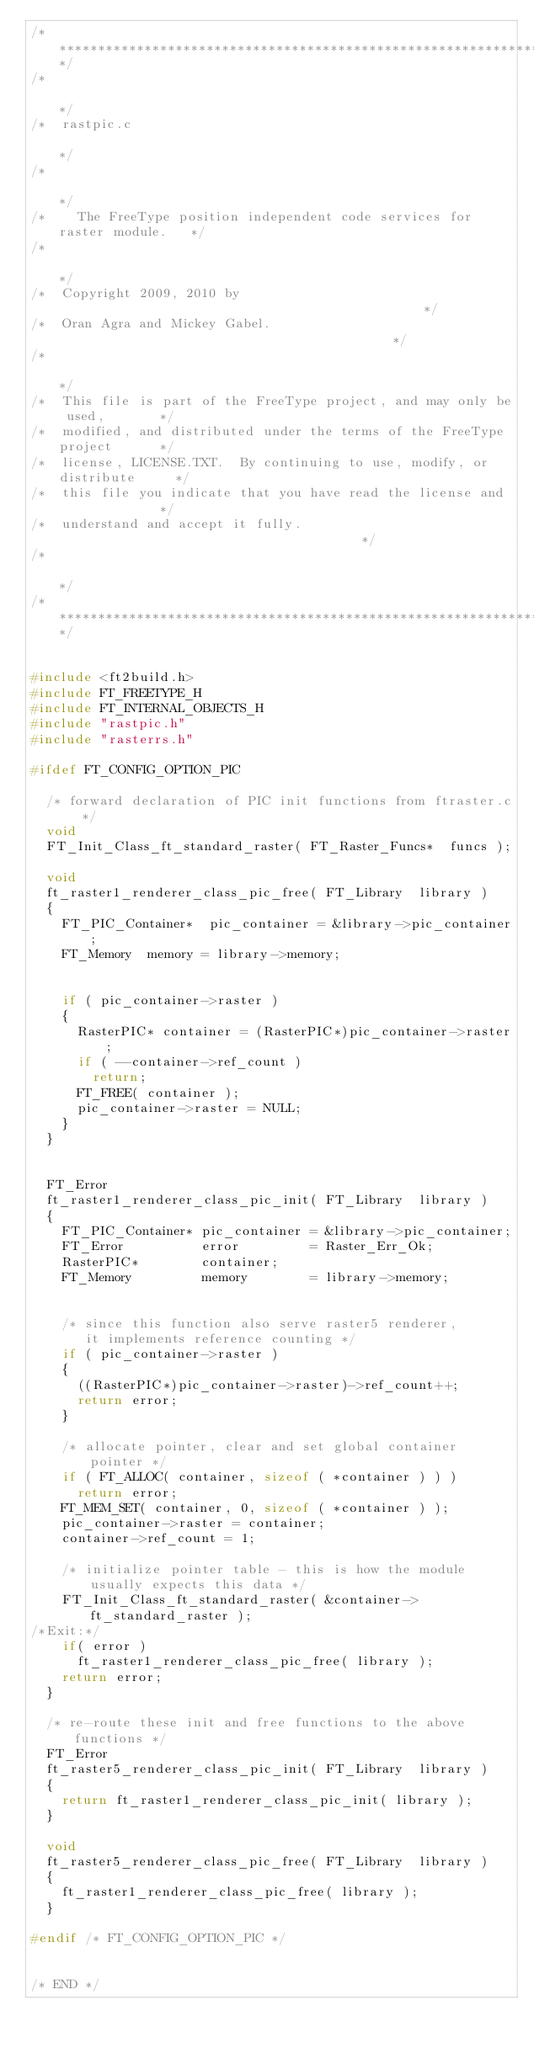Convert code to text. <code><loc_0><loc_0><loc_500><loc_500><_C_>/***************************************************************************/
/*                                                                         */
/*  rastpic.c                                                              */
/*                                                                         */
/*    The FreeType position independent code services for raster module.   */
/*                                                                         */
/*  Copyright 2009, 2010 by                                                */
/*  Oran Agra and Mickey Gabel.                                            */
/*                                                                         */
/*  This file is part of the FreeType project, and may only be used,       */
/*  modified, and distributed under the terms of the FreeType project      */
/*  license, LICENSE.TXT.  By continuing to use, modify, or distribute     */
/*  this file you indicate that you have read the license and              */
/*  understand and accept it fully.                                        */
/*                                                                         */
/***************************************************************************/


#include <ft2build.h>
#include FT_FREETYPE_H
#include FT_INTERNAL_OBJECTS_H
#include "rastpic.h"
#include "rasterrs.h"

#ifdef FT_CONFIG_OPTION_PIC

  /* forward declaration of PIC init functions from ftraster.c */
  void
  FT_Init_Class_ft_standard_raster( FT_Raster_Funcs*  funcs );

  void
  ft_raster1_renderer_class_pic_free( FT_Library  library )
  {
    FT_PIC_Container*  pic_container = &library->pic_container;
    FT_Memory  memory = library->memory;


    if ( pic_container->raster )
    {
      RasterPIC* container = (RasterPIC*)pic_container->raster;
      if ( --container->ref_count )
        return;
      FT_FREE( container );
      pic_container->raster = NULL;
    }
  }


  FT_Error
  ft_raster1_renderer_class_pic_init( FT_Library  library )
  {
    FT_PIC_Container* pic_container = &library->pic_container;
    FT_Error          error         = Raster_Err_Ok;
    RasterPIC*        container;
    FT_Memory         memory        = library->memory;


    /* since this function also serve raster5 renderer,
       it implements reference counting */
    if ( pic_container->raster )
    {
      ((RasterPIC*)pic_container->raster)->ref_count++;
      return error;
    }

    /* allocate pointer, clear and set global container pointer */
    if ( FT_ALLOC( container, sizeof ( *container ) ) )
      return error;
    FT_MEM_SET( container, 0, sizeof ( *container ) );
    pic_container->raster = container;
    container->ref_count = 1;

    /* initialize pointer table - this is how the module usually expects this data */
    FT_Init_Class_ft_standard_raster( &container->ft_standard_raster );
/*Exit:*/
    if( error )
      ft_raster1_renderer_class_pic_free( library );
    return error;
  }

  /* re-route these init and free functions to the above functions */
  FT_Error
  ft_raster5_renderer_class_pic_init( FT_Library  library )
  {
    return ft_raster1_renderer_class_pic_init( library );
  }

  void
  ft_raster5_renderer_class_pic_free( FT_Library  library )
  {
    ft_raster1_renderer_class_pic_free( library );
  }

#endif /* FT_CONFIG_OPTION_PIC */


/* END */
</code> 